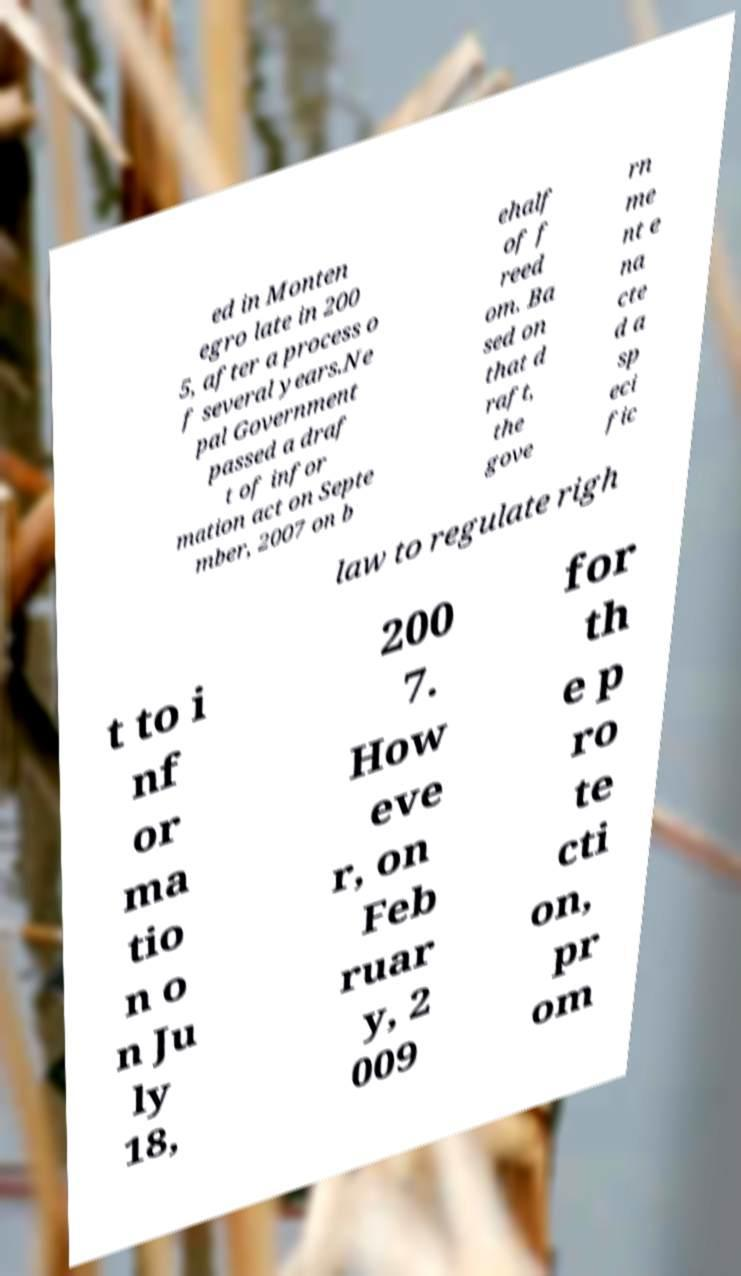I need the written content from this picture converted into text. Can you do that? ed in Monten egro late in 200 5, after a process o f several years.Ne pal Government passed a draf t of infor mation act on Septe mber, 2007 on b ehalf of f reed om. Ba sed on that d raft, the gove rn me nt e na cte d a sp eci fic law to regulate righ t to i nf or ma tio n o n Ju ly 18, 200 7. How eve r, on Feb ruar y, 2 009 for th e p ro te cti on, pr om 